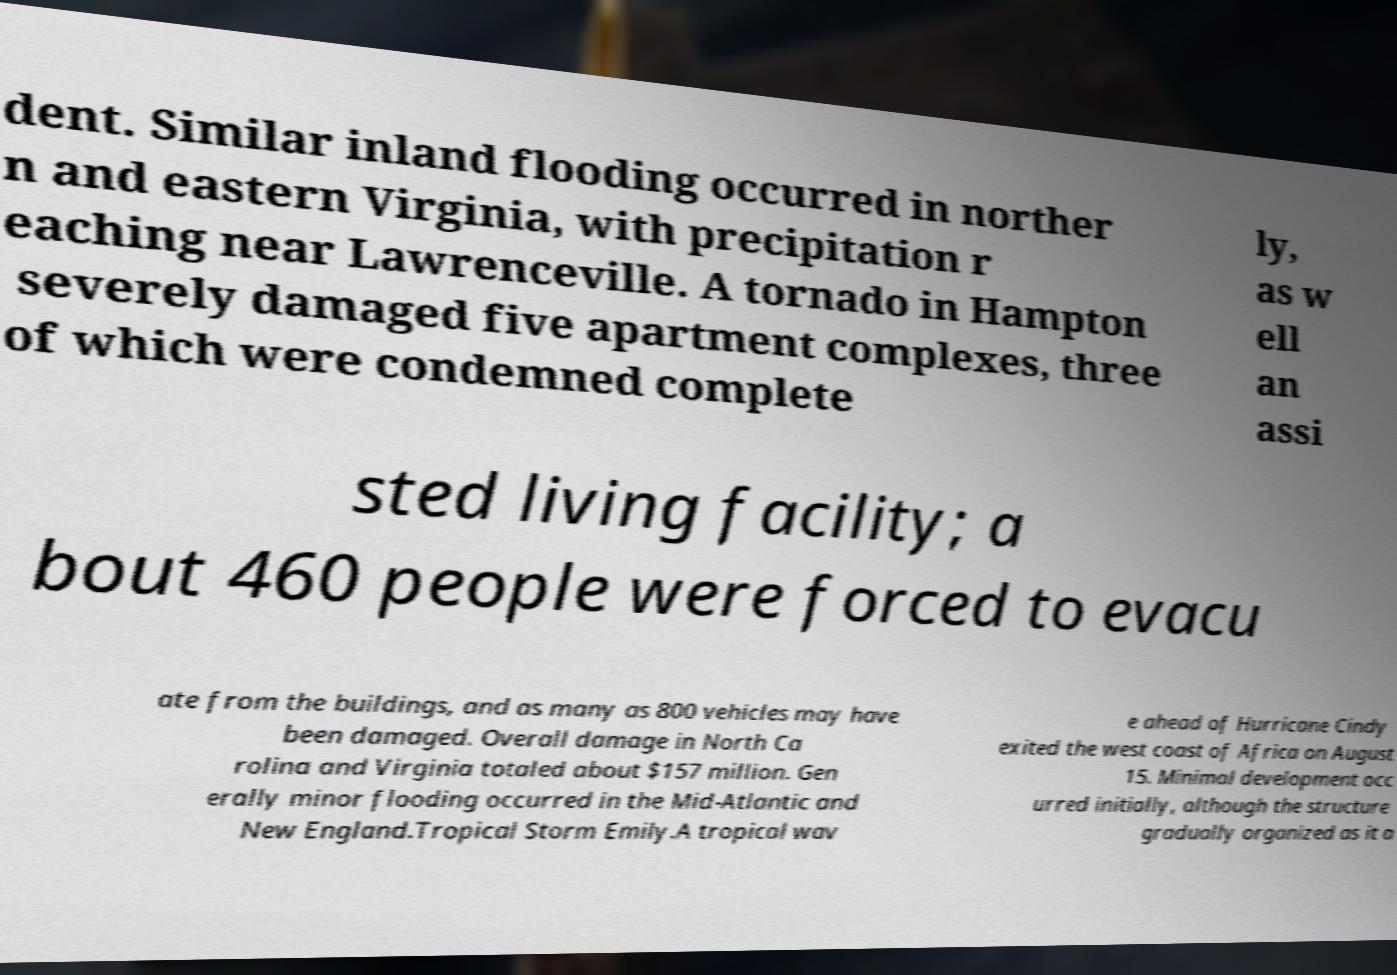Could you extract and type out the text from this image? dent. Similar inland flooding occurred in norther n and eastern Virginia, with precipitation r eaching near Lawrenceville. A tornado in Hampton severely damaged five apartment complexes, three of which were condemned complete ly, as w ell an assi sted living facility; a bout 460 people were forced to evacu ate from the buildings, and as many as 800 vehicles may have been damaged. Overall damage in North Ca rolina and Virginia totaled about $157 million. Gen erally minor flooding occurred in the Mid-Atlantic and New England.Tropical Storm Emily.A tropical wav e ahead of Hurricane Cindy exited the west coast of Africa on August 15. Minimal development occ urred initially, although the structure gradually organized as it a 